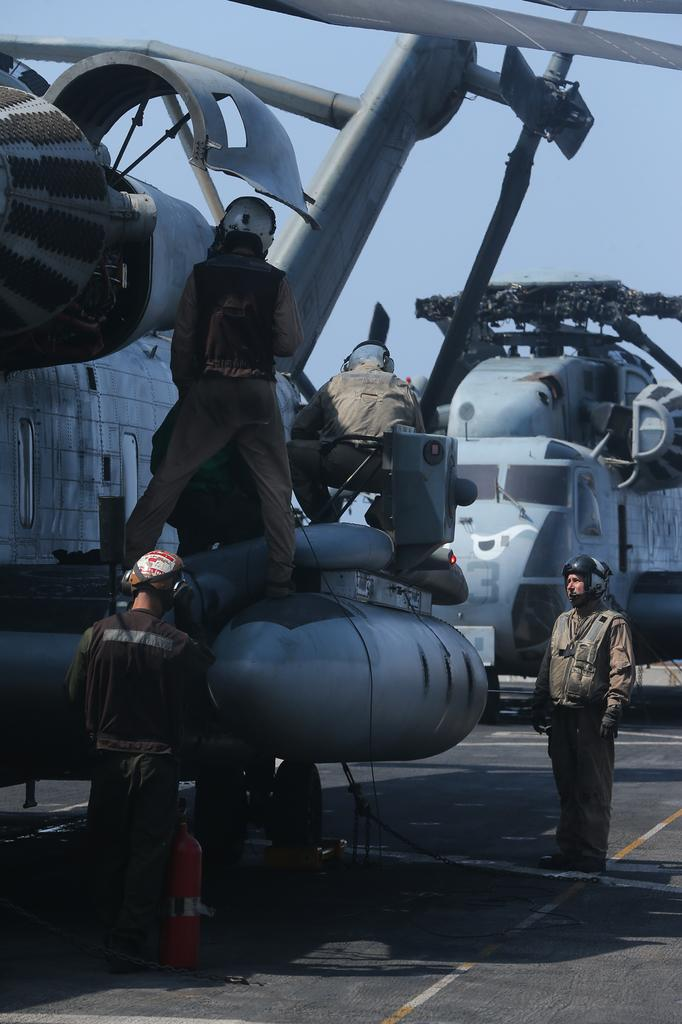What is the main subject of the image? The main subject of the image is airplanes. Where are the airplanes located in the image? The airplanes are in the center of the image. What are the people near the airplanes doing? The people standing near the airplanes are wearing helmets. What can be seen in the background of the image? The sky is visible in the background of the image. What type of tools is the carpenter using in the image? There is no carpenter present in the image, and therefore no tools can be observed. How many boys are visible in the image? There is no boy present in the image; it features airplanes and people wearing helmets. 